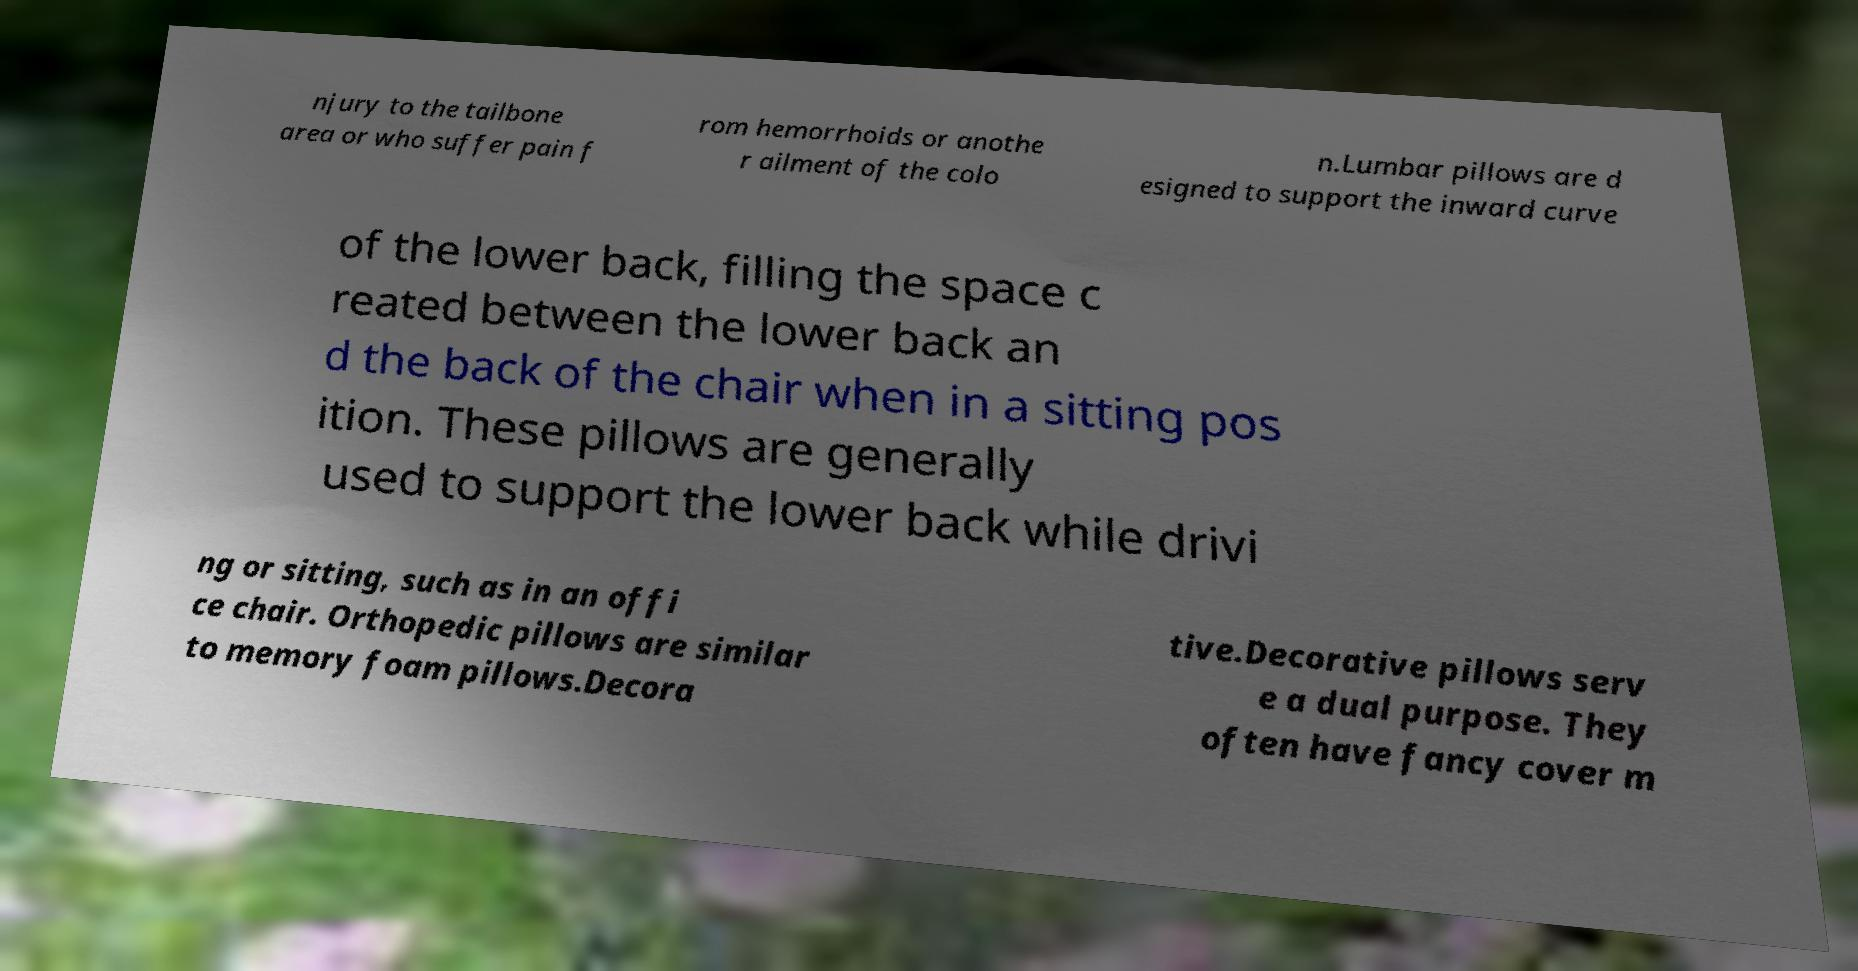Can you accurately transcribe the text from the provided image for me? njury to the tailbone area or who suffer pain f rom hemorrhoids or anothe r ailment of the colo n.Lumbar pillows are d esigned to support the inward curve of the lower back, filling the space c reated between the lower back an d the back of the chair when in a sitting pos ition. These pillows are generally used to support the lower back while drivi ng or sitting, such as in an offi ce chair. Orthopedic pillows are similar to memory foam pillows.Decora tive.Decorative pillows serv e a dual purpose. They often have fancy cover m 